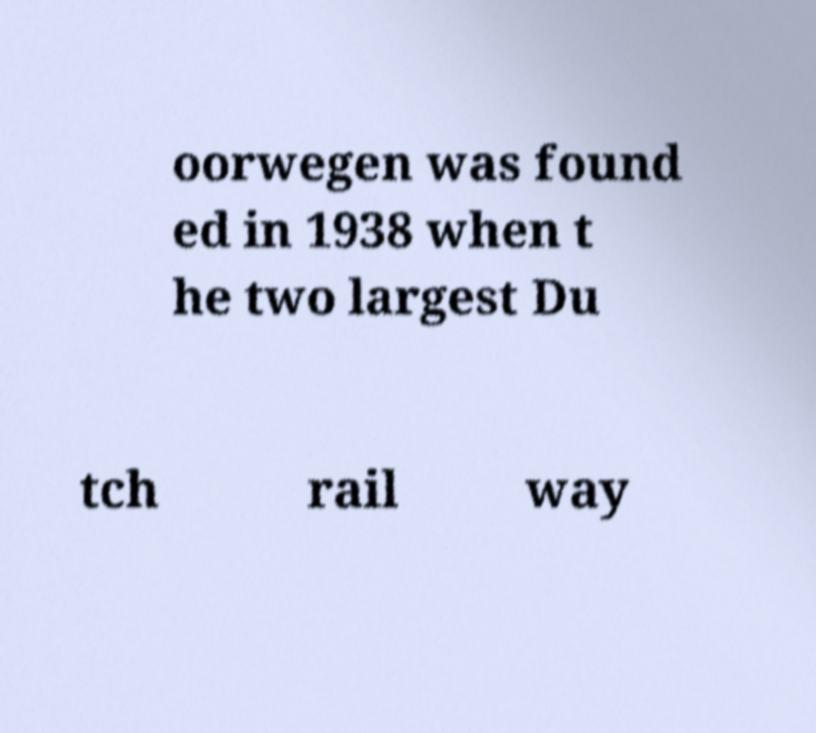Can you read and provide the text displayed in the image?This photo seems to have some interesting text. Can you extract and type it out for me? oorwegen was found ed in 1938 when t he two largest Du tch rail way 